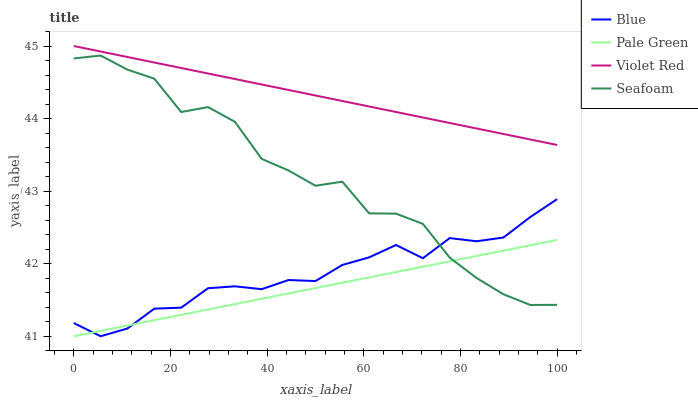Does Pale Green have the minimum area under the curve?
Answer yes or no. Yes. Does Violet Red have the maximum area under the curve?
Answer yes or no. Yes. Does Violet Red have the minimum area under the curve?
Answer yes or no. No. Does Pale Green have the maximum area under the curve?
Answer yes or no. No. Is Pale Green the smoothest?
Answer yes or no. Yes. Is Seafoam the roughest?
Answer yes or no. Yes. Is Violet Red the smoothest?
Answer yes or no. No. Is Violet Red the roughest?
Answer yes or no. No. Does Blue have the lowest value?
Answer yes or no. Yes. Does Violet Red have the lowest value?
Answer yes or no. No. Does Violet Red have the highest value?
Answer yes or no. Yes. Does Pale Green have the highest value?
Answer yes or no. No. Is Seafoam less than Violet Red?
Answer yes or no. Yes. Is Violet Red greater than Pale Green?
Answer yes or no. Yes. Does Pale Green intersect Seafoam?
Answer yes or no. Yes. Is Pale Green less than Seafoam?
Answer yes or no. No. Is Pale Green greater than Seafoam?
Answer yes or no. No. Does Seafoam intersect Violet Red?
Answer yes or no. No. 